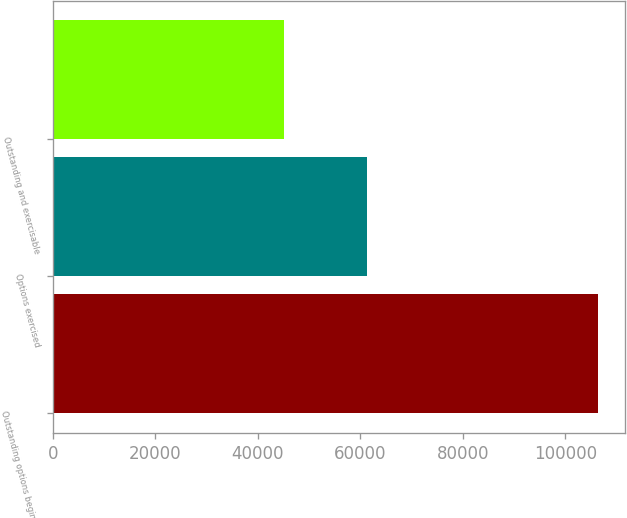<chart> <loc_0><loc_0><loc_500><loc_500><bar_chart><fcel>Outstanding options beginning<fcel>Options exercised<fcel>Outstanding and exercisable<nl><fcel>106368<fcel>61361<fcel>45007<nl></chart> 